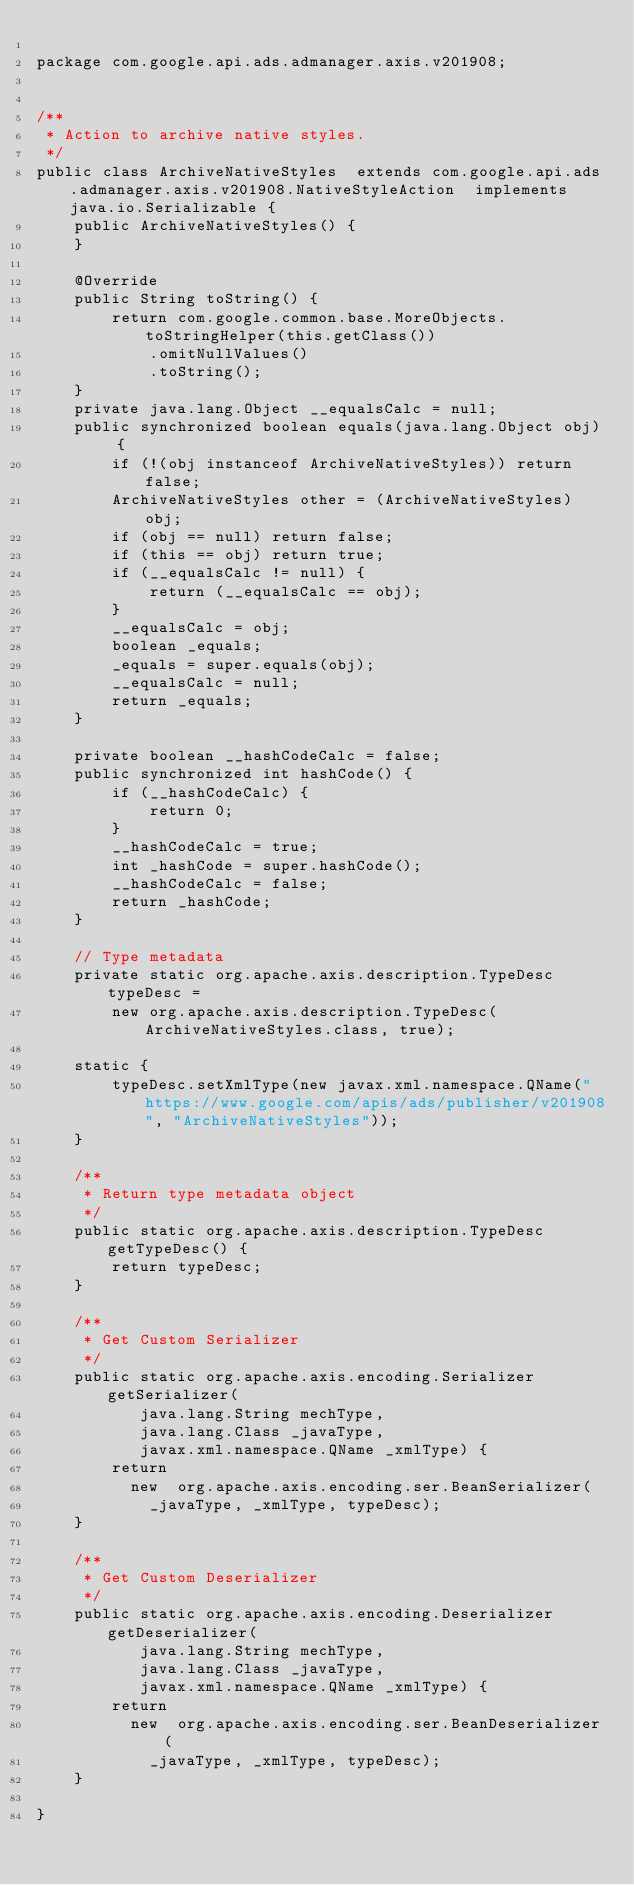Convert code to text. <code><loc_0><loc_0><loc_500><loc_500><_Java_>
package com.google.api.ads.admanager.axis.v201908;


/**
 * Action to archive native styles.
 */
public class ArchiveNativeStyles  extends com.google.api.ads.admanager.axis.v201908.NativeStyleAction  implements java.io.Serializable {
    public ArchiveNativeStyles() {
    }

    @Override
    public String toString() {
        return com.google.common.base.MoreObjects.toStringHelper(this.getClass())
            .omitNullValues()
            .toString();
    }
    private java.lang.Object __equalsCalc = null;
    public synchronized boolean equals(java.lang.Object obj) {
        if (!(obj instanceof ArchiveNativeStyles)) return false;
        ArchiveNativeStyles other = (ArchiveNativeStyles) obj;
        if (obj == null) return false;
        if (this == obj) return true;
        if (__equalsCalc != null) {
            return (__equalsCalc == obj);
        }
        __equalsCalc = obj;
        boolean _equals;
        _equals = super.equals(obj);
        __equalsCalc = null;
        return _equals;
    }

    private boolean __hashCodeCalc = false;
    public synchronized int hashCode() {
        if (__hashCodeCalc) {
            return 0;
        }
        __hashCodeCalc = true;
        int _hashCode = super.hashCode();
        __hashCodeCalc = false;
        return _hashCode;
    }

    // Type metadata
    private static org.apache.axis.description.TypeDesc typeDesc =
        new org.apache.axis.description.TypeDesc(ArchiveNativeStyles.class, true);

    static {
        typeDesc.setXmlType(new javax.xml.namespace.QName("https://www.google.com/apis/ads/publisher/v201908", "ArchiveNativeStyles"));
    }

    /**
     * Return type metadata object
     */
    public static org.apache.axis.description.TypeDesc getTypeDesc() {
        return typeDesc;
    }

    /**
     * Get Custom Serializer
     */
    public static org.apache.axis.encoding.Serializer getSerializer(
           java.lang.String mechType, 
           java.lang.Class _javaType,  
           javax.xml.namespace.QName _xmlType) {
        return 
          new  org.apache.axis.encoding.ser.BeanSerializer(
            _javaType, _xmlType, typeDesc);
    }

    /**
     * Get Custom Deserializer
     */
    public static org.apache.axis.encoding.Deserializer getDeserializer(
           java.lang.String mechType, 
           java.lang.Class _javaType,  
           javax.xml.namespace.QName _xmlType) {
        return 
          new  org.apache.axis.encoding.ser.BeanDeserializer(
            _javaType, _xmlType, typeDesc);
    }

}
</code> 